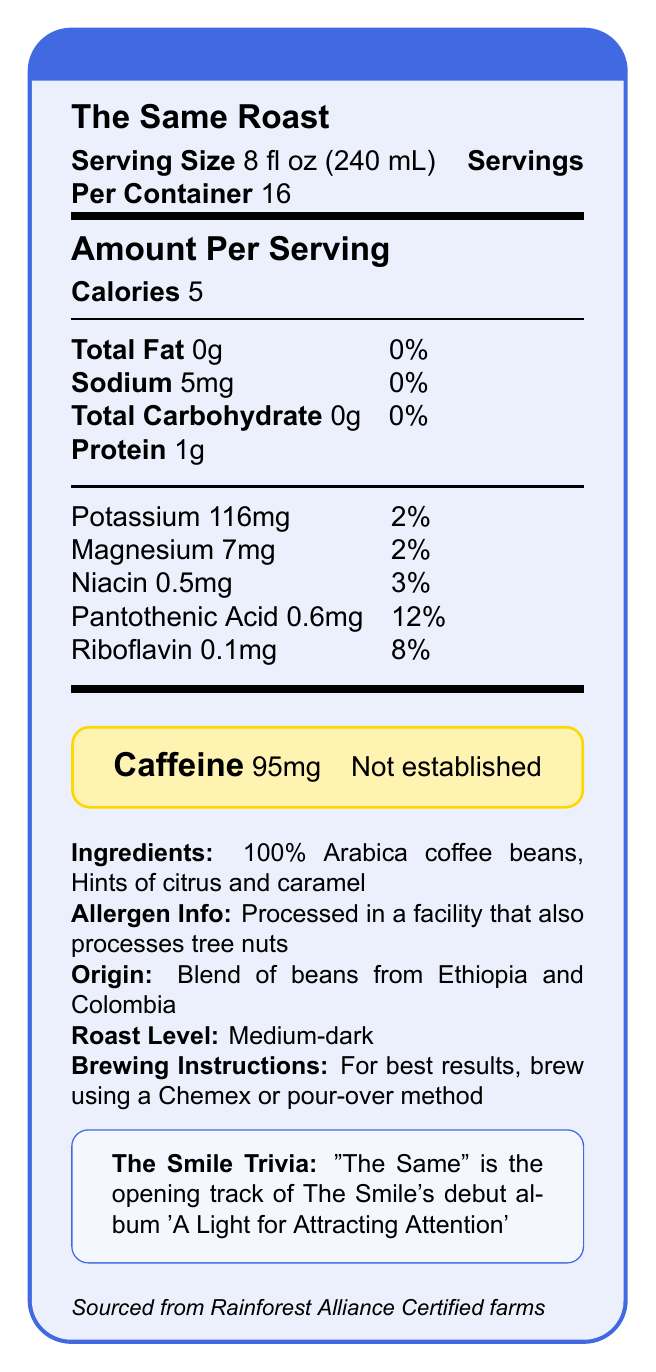what is the serving size? The document states the serving size as 8 fl oz (240 mL) under the "Serving Size" section.
Answer: 8 fl oz (240 mL) how many calories are there per serving? The document specifies that there are 5 calories per serving in the "Amount Per Serving" section.
Answer: 5 how much protein is in one serving? The document lists the protein content as 1g in the "Amount Per Serving" section.
Answer: 1g how much caffeine is in one serving? The highlighted "Caffeine" section of the document states there are 95mg of caffeine per serving.
Answer: 95mg what is the product name? The product name, "The Same Roast," is prominently displayed at the beginning of the document.
Answer: The Same Roast which nutrient has the highest daily value percentage per serving? A. Sodium B. Pantothenic Acid C. Magnesium D. Riboflavin Pantothenic Acid has the highest daily value percentage at 12% as per the "Amount Per Serving" section.
Answer: B what is the origin of the coffee beans? A. Peru B. Ethiopia and Colombia C. Brazil D. Kenya and Ethiopia The document specifies the origin as a blend of beans from Ethiopia and Colombia, stated in the "Origin" section.
Answer: B is this product sourced sustainably? The document notes that this coffee is sourced from Rainforest Alliance Certified farms, which indicates sustainable sourcing.
Answer: Yes are there any allergens in this product? The document includes an "Allergen Info" section stating that it is processed in a facility that also processes tree nuts.
Answer: Yes summarize the entire document. The document provides detailed nutritional facts about "The Same Roast," a specialty coffee blend. It includes serving size, calories, protein, and caffeine content. Additionally, there are specific details on the coffee's origin, ingredients, allergen information, and sustainability. It also includes trivia related to The Smile band.
Answer: The Same Roast is a specialty coffee blend named after a The Smile song. It contains 5 calories per 8 fl oz serving, with 95mg of caffeine. The coffee is a medium-dark roast made from Arabica beans sourced from Ethiopia and Colombia. It includes nutritional information, ingredients, allergen details, brewing instructions, and a note on the band's trivia. The coffee is sourced sustainably from Rainforest Alliance Certified farms. what are the brewing instructions? The brewing instructions section suggests using a Chemex or pour-over method for best results.
Answer: For best results, brew using a Chemex or pour-over method how many servings are in one container? The document states that there are 16 servings per container under the "Serving Size" and "Servings Per Container" section.
Answer: 16 identify one vitamin mentioned in the document along with its daily value percentage. The document lists Riboflavin with a daily value percentage of 8% in the "Amount Per Serving" section containing vitamins and minerals.
Answer: Riboflavin, 8% what album is the trivia about? The trivia section mentions "The Same" is the opening track of The Smile’s debut album 'A Light for Attracting Attention'.
Answer: 'A Light for Attracting Attention' how much total fat is in one serving? The document indicates total fat content as 0g in the "Amount Per Serving" section.
Answer: 0g is there any fruit flavor mentioned? The "Ingredients" section lists "Hints of citrus and caramel," indicating a fruit flavor.
Answer: Yes, citrus does this coffee contain sugar? The document does not mention sugar or total sugars; therefore, it's unclear if sugar is present or not.
Answer: Not enough information what is the roast level of this coffee? The document clearly states the roast level is medium-dark in the "Roast Level" section.
Answer: Medium-dark 